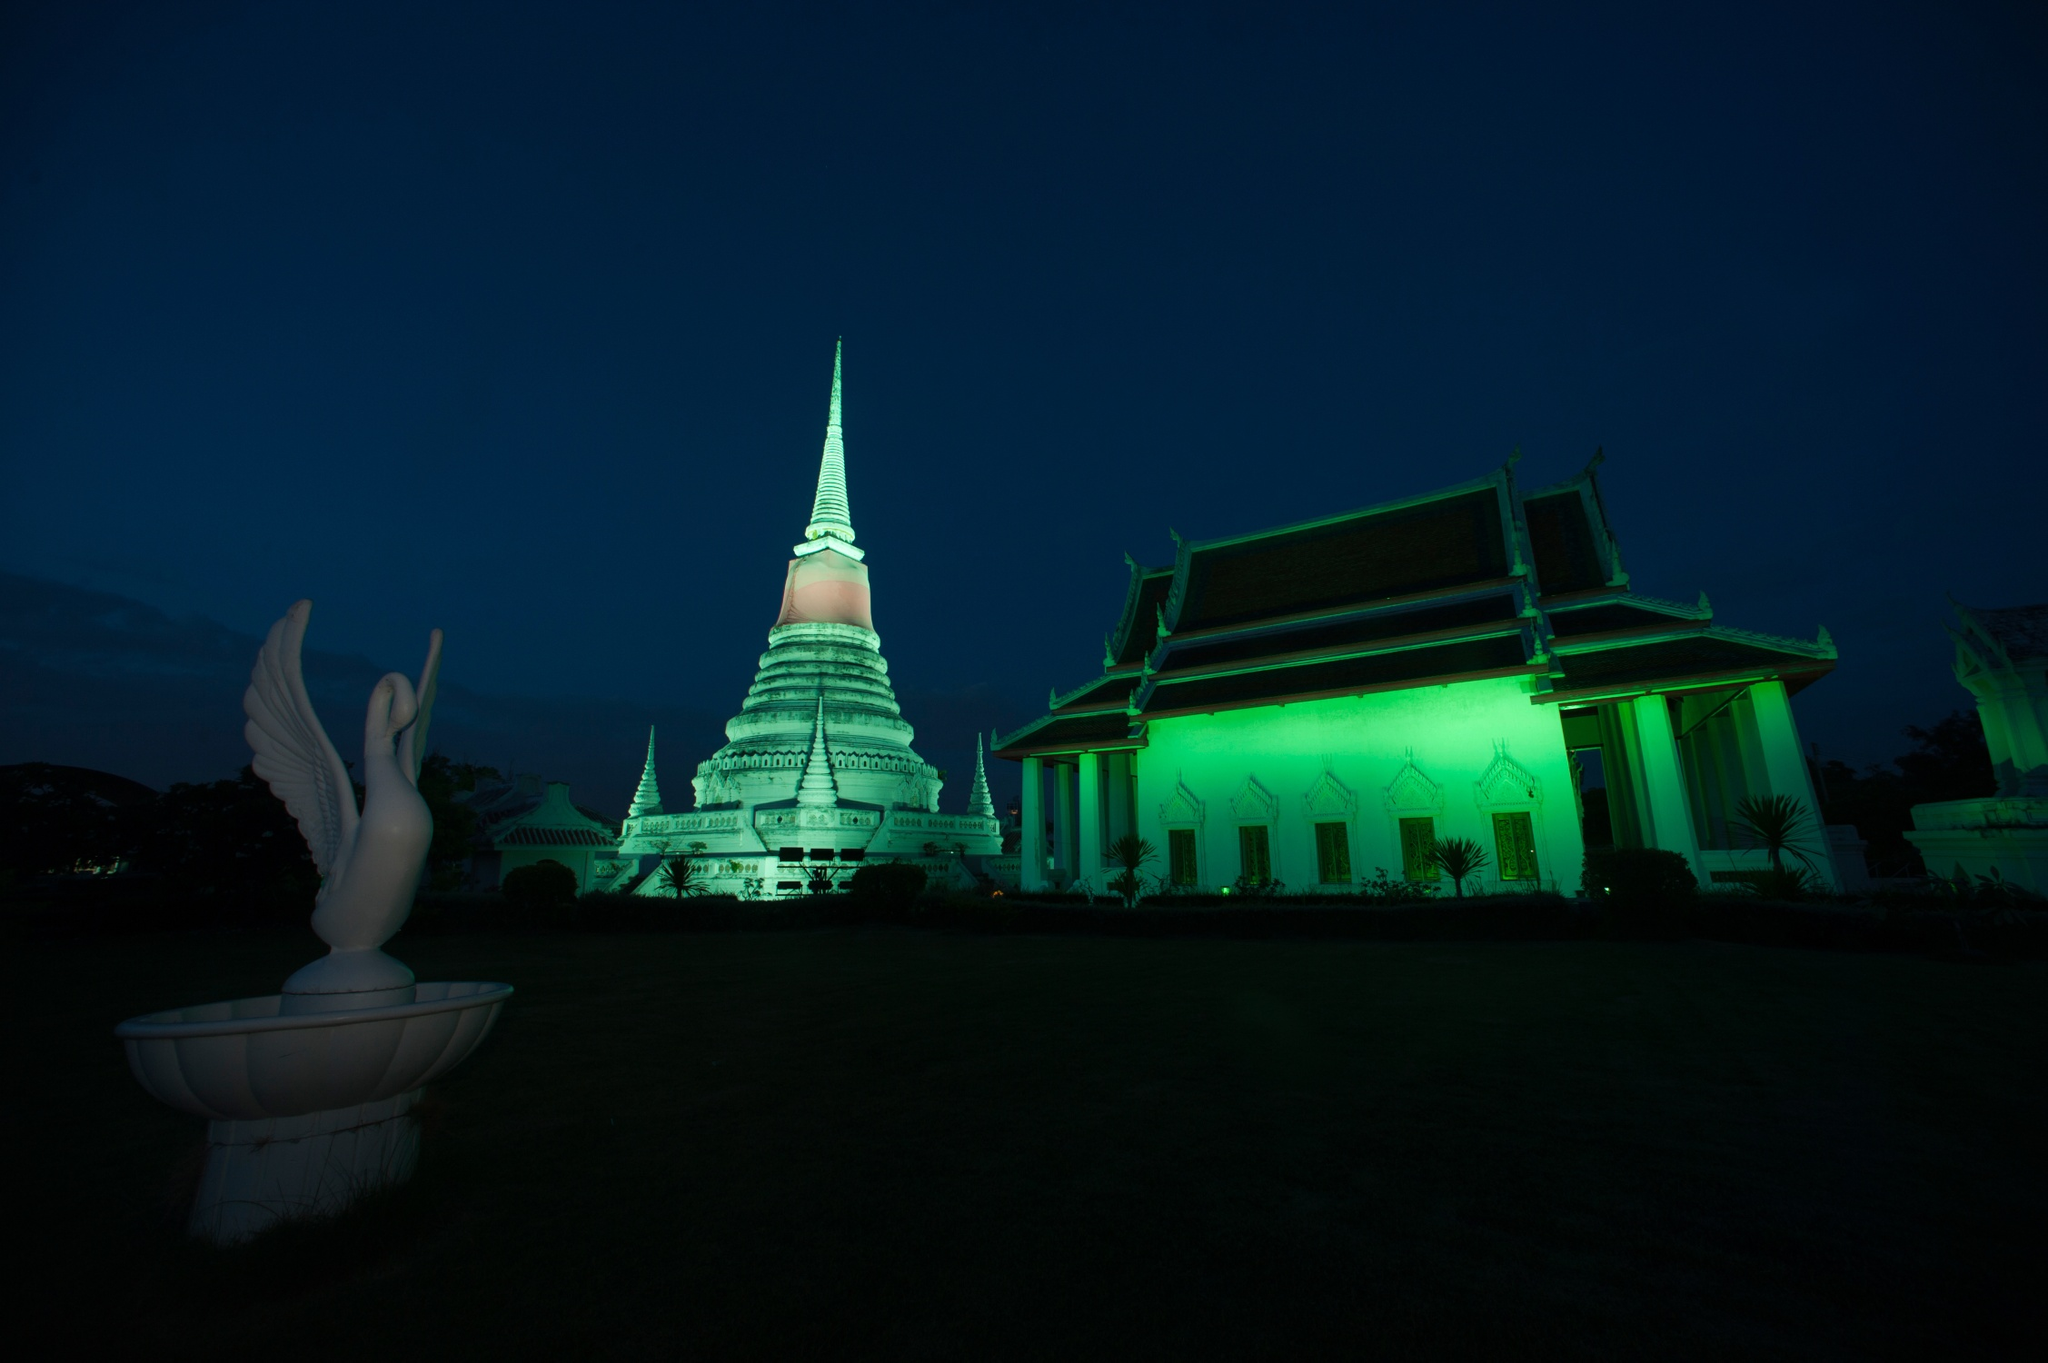Imagine a festival occurring at this temple. What events might you see? During a festival at this temple, you would likely see a vibrant array of activities. There would be monks chanting prayers, people making offerings, and traditional Thai music filling the air. The temple grounds might be adorned with colorful lanterns and flowers. A procession of devotees in traditional attire could be seen, carrying candles and incense, moving in a peaceful and orderly manner around the temple. Food stalls offering local delicacies might be set up, adding a festive aroma and a sense of community celebration. 